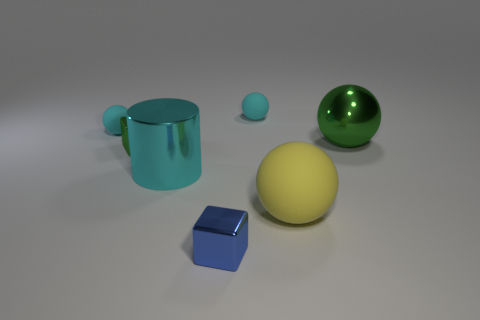Is there any other thing that has the same shape as the blue object?
Offer a terse response. Yes. Is the material of the blue object the same as the sphere that is right of the yellow thing?
Provide a succinct answer. Yes. What is the color of the tiny shiny object that is in front of the big yellow ball that is in front of the cyan thing that is in front of the big metallic ball?
Keep it short and to the point. Blue. Are there any other things that are the same size as the shiny ball?
Provide a succinct answer. Yes. There is a metallic ball; is it the same color as the thing that is in front of the yellow rubber object?
Your answer should be compact. No. The metal sphere is what color?
Keep it short and to the point. Green. The tiny object in front of the cylinder that is on the left side of the tiny metallic thing in front of the yellow sphere is what shape?
Ensure brevity in your answer.  Cube. What number of other objects are there of the same color as the cylinder?
Offer a very short reply. 2. Are there more large yellow matte spheres in front of the large yellow thing than spheres that are in front of the big green metal sphere?
Provide a short and direct response. No. Are there any yellow spheres right of the blue shiny thing?
Your answer should be very brief. Yes. 